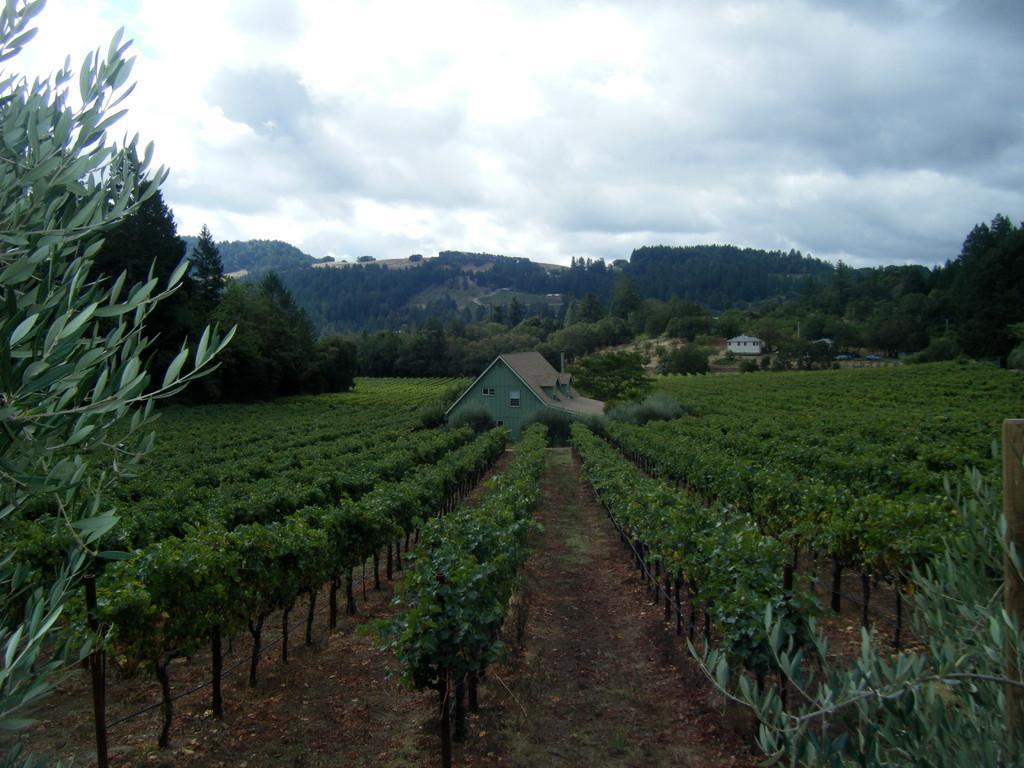Can you describe this image briefly? There are some plants on the ground at the bottom of this image. There is a house in the middle of this image and there are some trees in the background. There is a cloudy sky at the top of this image. 